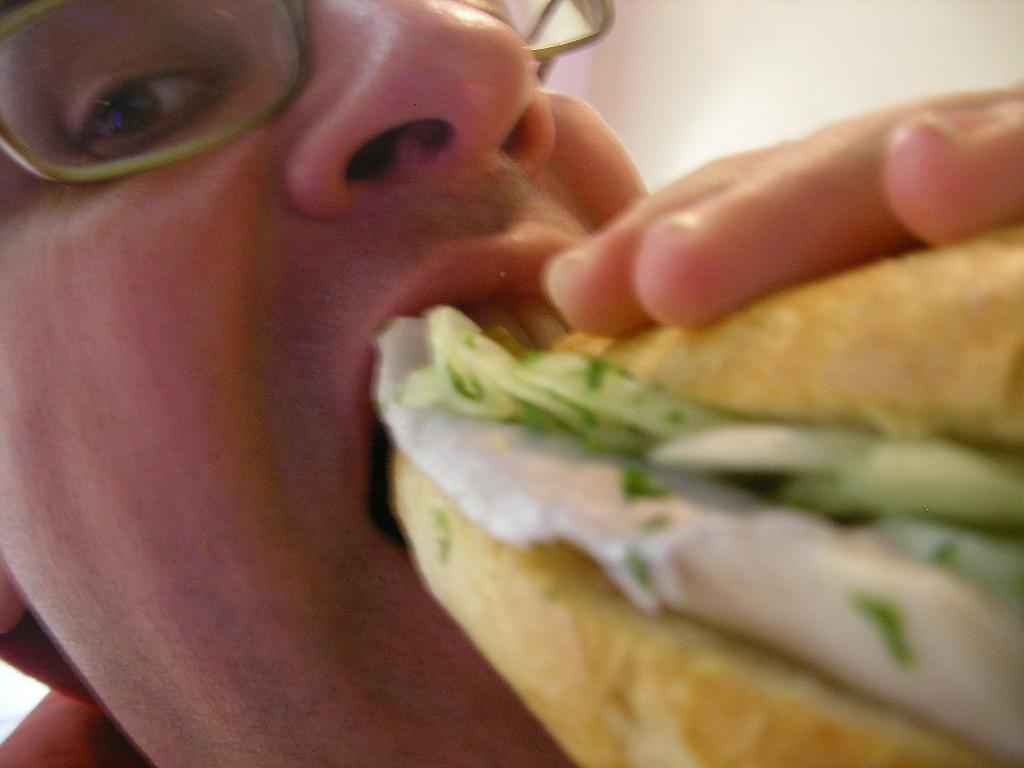What is happening in the image? There is a person in the image who is eating a food item. Can you describe the surroundings of the person? There is a wall visible in the image. How many sisters does the person in the image have? There is no information about the person's sisters in the image. What type of farm can be seen in the background of the image? There is no farm present in the image; it only shows a person eating and a wall. 